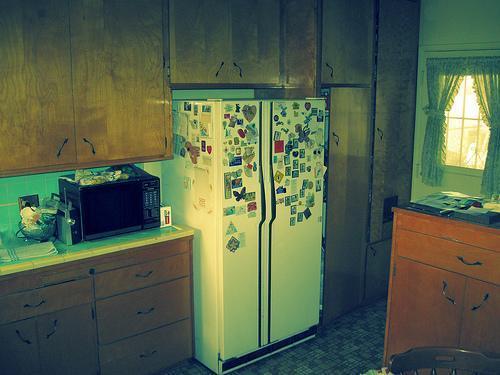How many refrigerators?
Give a very brief answer. 1. How many chairs?
Give a very brief answer. 1. How many curtains?
Give a very brief answer. 2. 